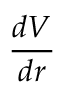<formula> <loc_0><loc_0><loc_500><loc_500>\frac { d V } { d r }</formula> 